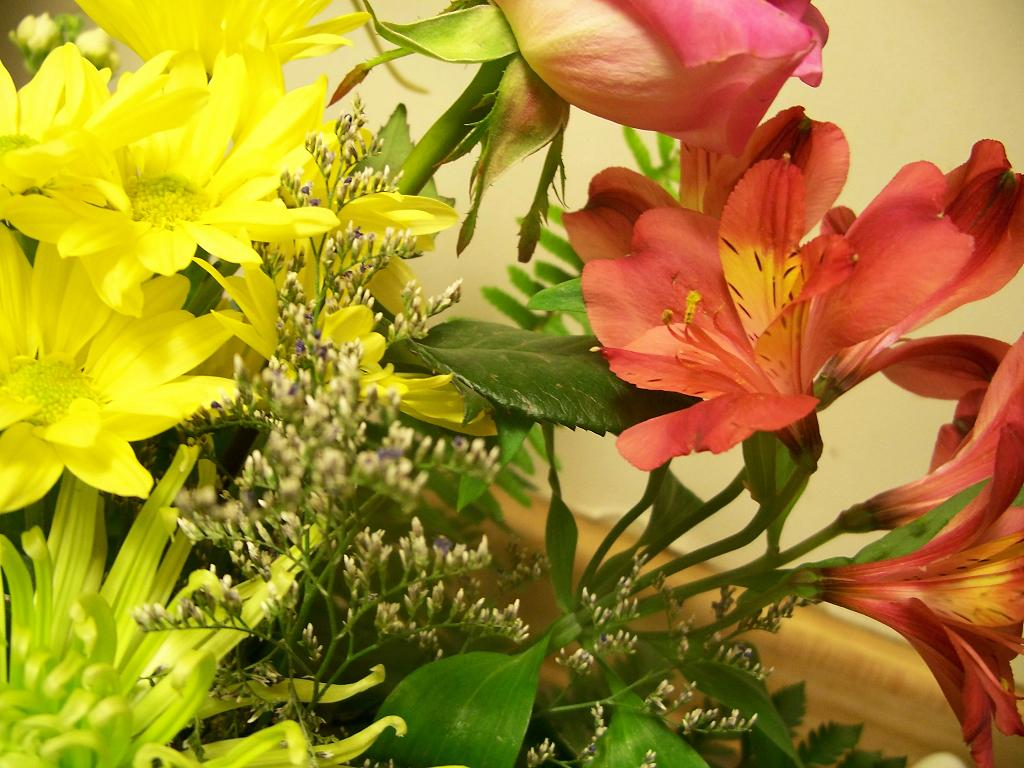What type of living organism is present in the image? There is a plant in the image. What specific feature of the plant is mentioned in the facts? The plant has flowers. What colors are the flowers? The flowers are yellow, red, and pink in color. What can be seen behind the plant in the image? There is a wall visible behind the plant. What type of government is in power during the recess depicted in the image? There is no recess or government mentioned in the image; it features a plant with flowers and a wall in the background. 